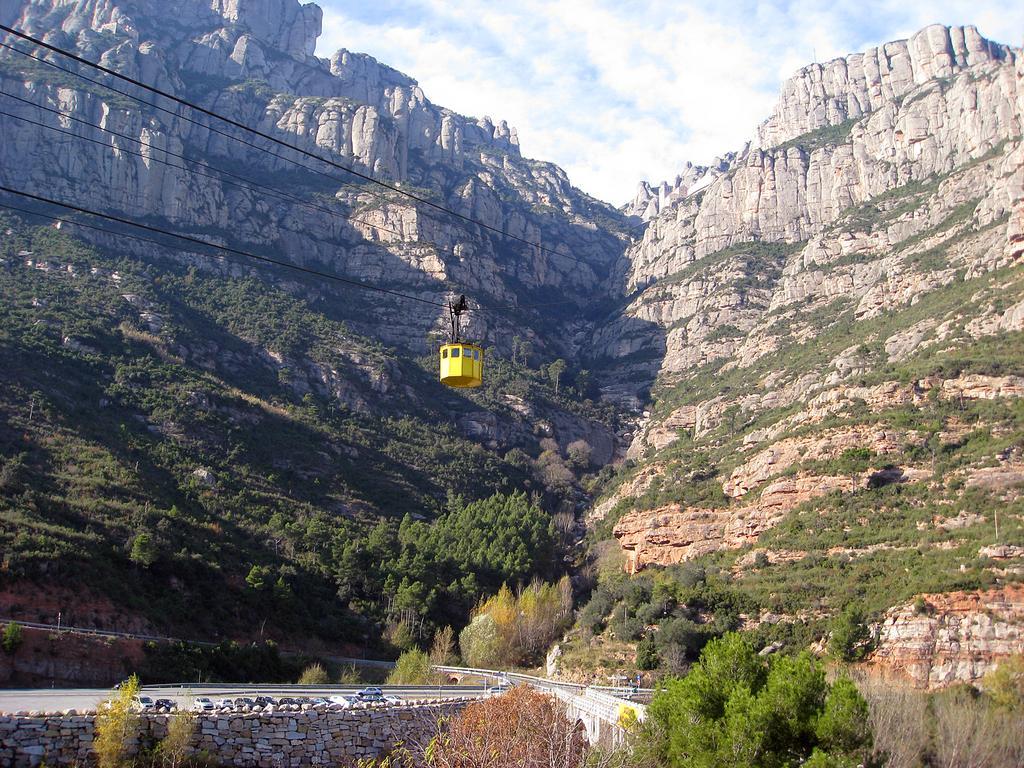Describe this image in one or two sentences. In this image I can see the cable car, few trees in green color. In the background I can see few rocks and the sky is in blue and white color. 